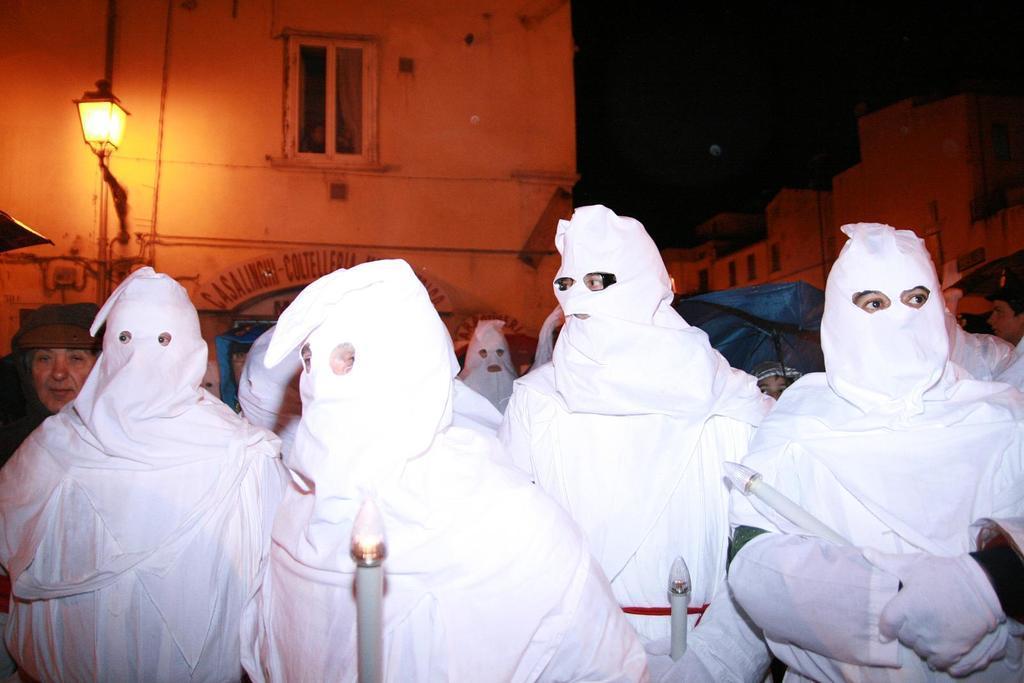Could you give a brief overview of what you see in this image? In this image we can see a group of people and few people are holding some objects in their hands. There are few buildings and they are having windows. There is a lamp attached to the building at the left side of the image. There is some text on the wall of the building. 